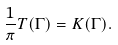<formula> <loc_0><loc_0><loc_500><loc_500>\frac { 1 } { \pi } T ( \Gamma ) = K ( \Gamma ) .</formula> 